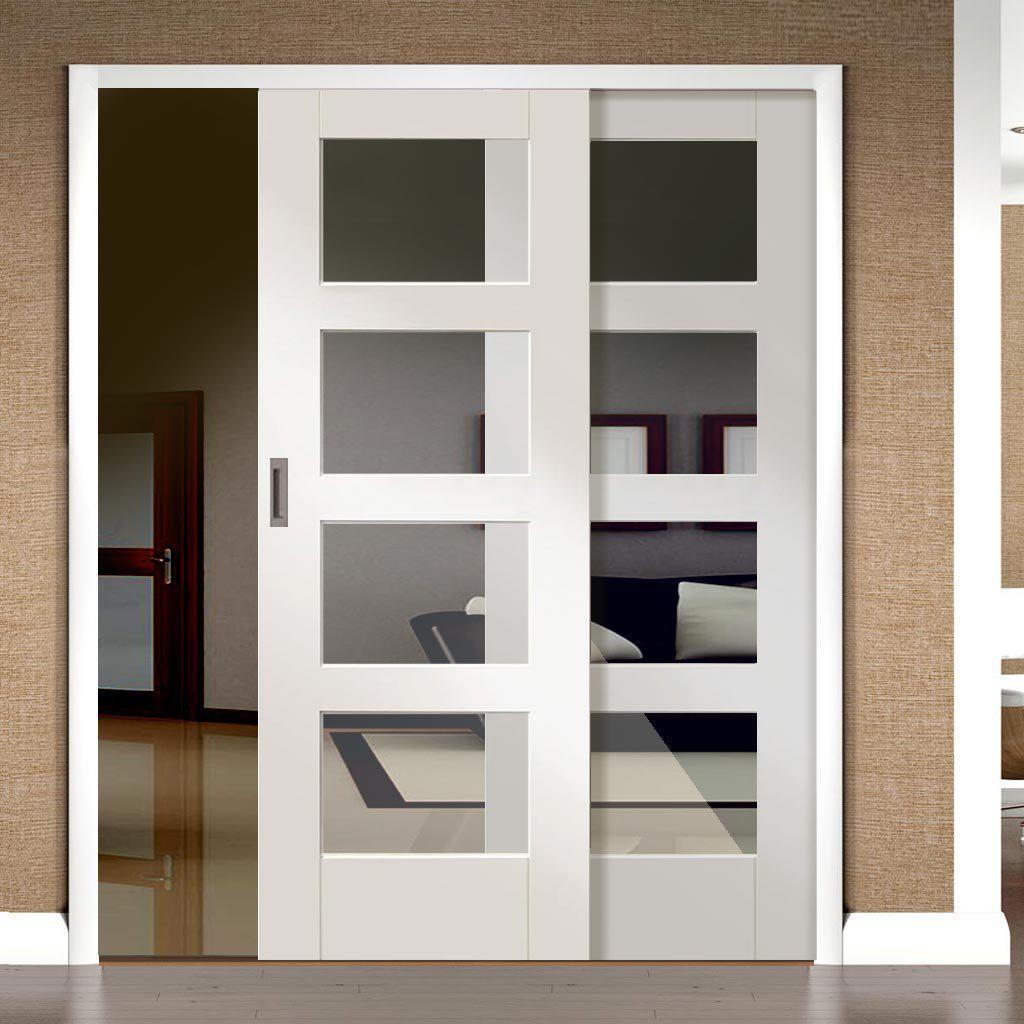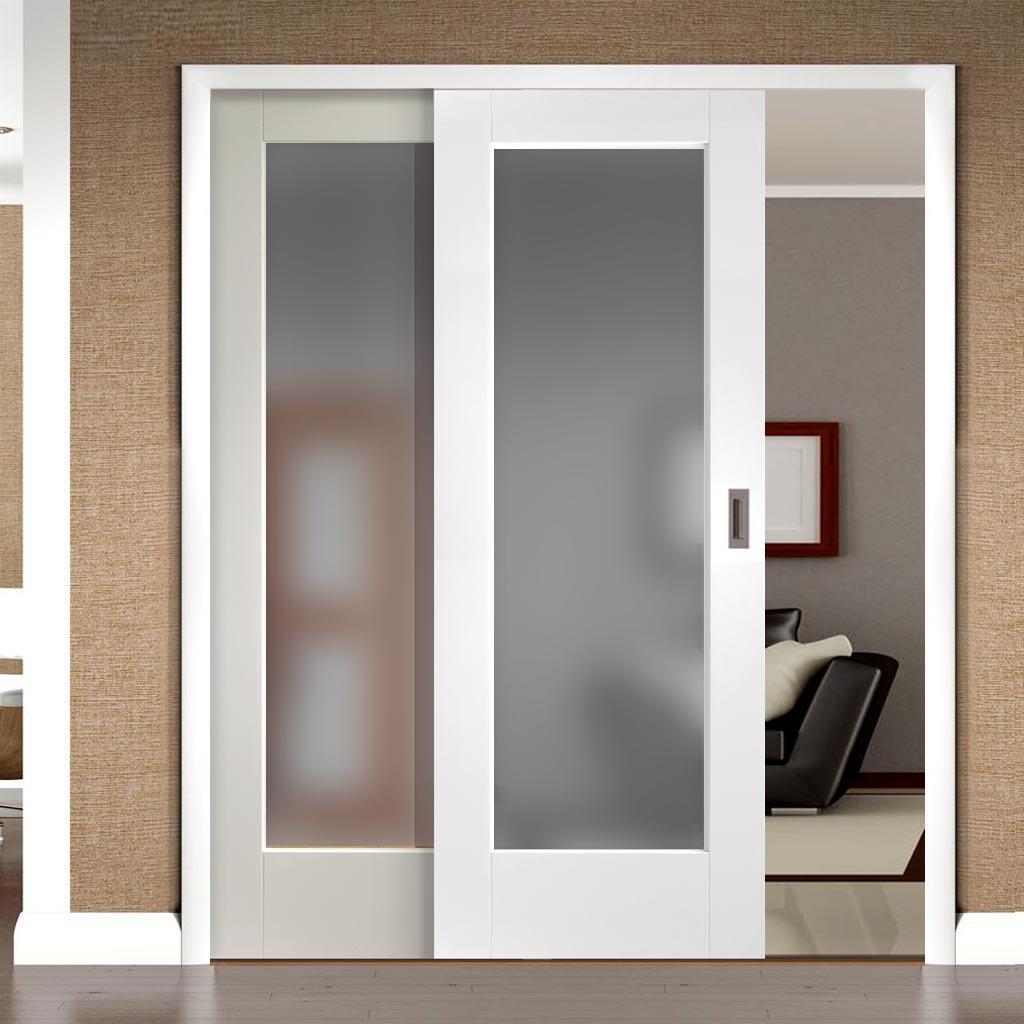The first image is the image on the left, the second image is the image on the right. Analyze the images presented: Is the assertion "Each image shows equal sized white double sliding doors with decorative panels, with one door with visible hardware partially opened." valid? Answer yes or no. Yes. The first image is the image on the left, the second image is the image on the right. For the images displayed, is the sentence "An image shows a white-framed sliding door partly opened on the right, revealing a square framed item on the wall." factually correct? Answer yes or no. Yes. 